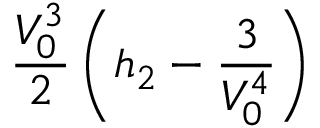Convert formula to latex. <formula><loc_0><loc_0><loc_500><loc_500>\frac { V _ { 0 } ^ { 3 } } { 2 } \left ( h _ { 2 } - \frac { 3 } { V _ { 0 } ^ { 4 } } \right )</formula> 